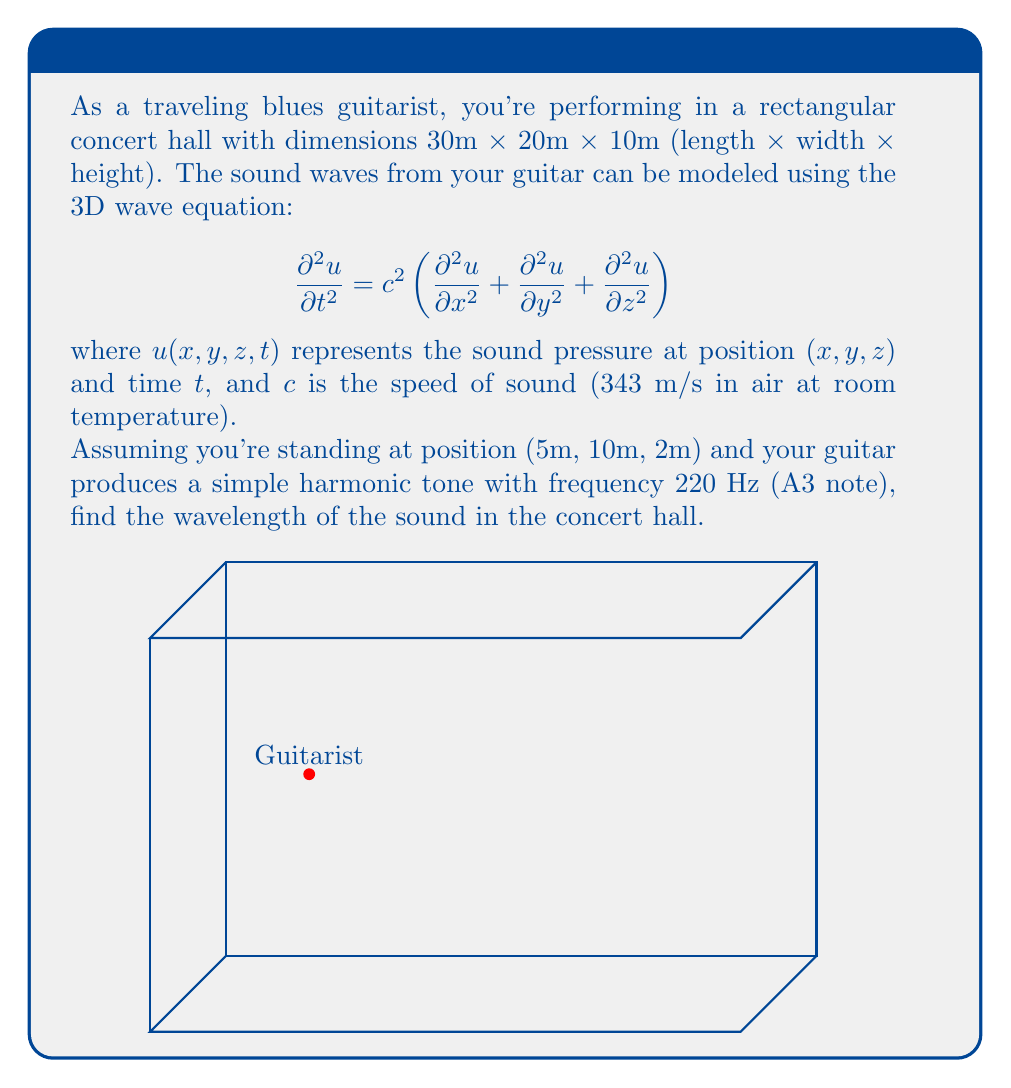Could you help me with this problem? To solve this problem, we'll follow these steps:

1) The wavelength $\lambda$ is related to the frequency $f$ and speed of sound $c$ by the equation:

   $$c = f\lambda$$

2) We're given:
   - Speed of sound: $c = 343$ m/s
   - Frequency: $f = 220$ Hz

3) Rearranging the equation to solve for $\lambda$:

   $$\lambda = \frac{c}{f}$$

4) Substituting the values:

   $$\lambda = \frac{343 \text{ m/s}}{220 \text{ Hz}}$$

5) Calculating:

   $$\lambda = 1.5590909... \text{ m}$$

6) Rounding to three decimal places:

   $$\lambda \approx 1.559 \text{ m}$$

This wavelength represents the spatial period of the sound wave in the concert hall, which is the distance between consecutive crests or troughs of the wave.
Answer: $\lambda \approx 1.559$ m 